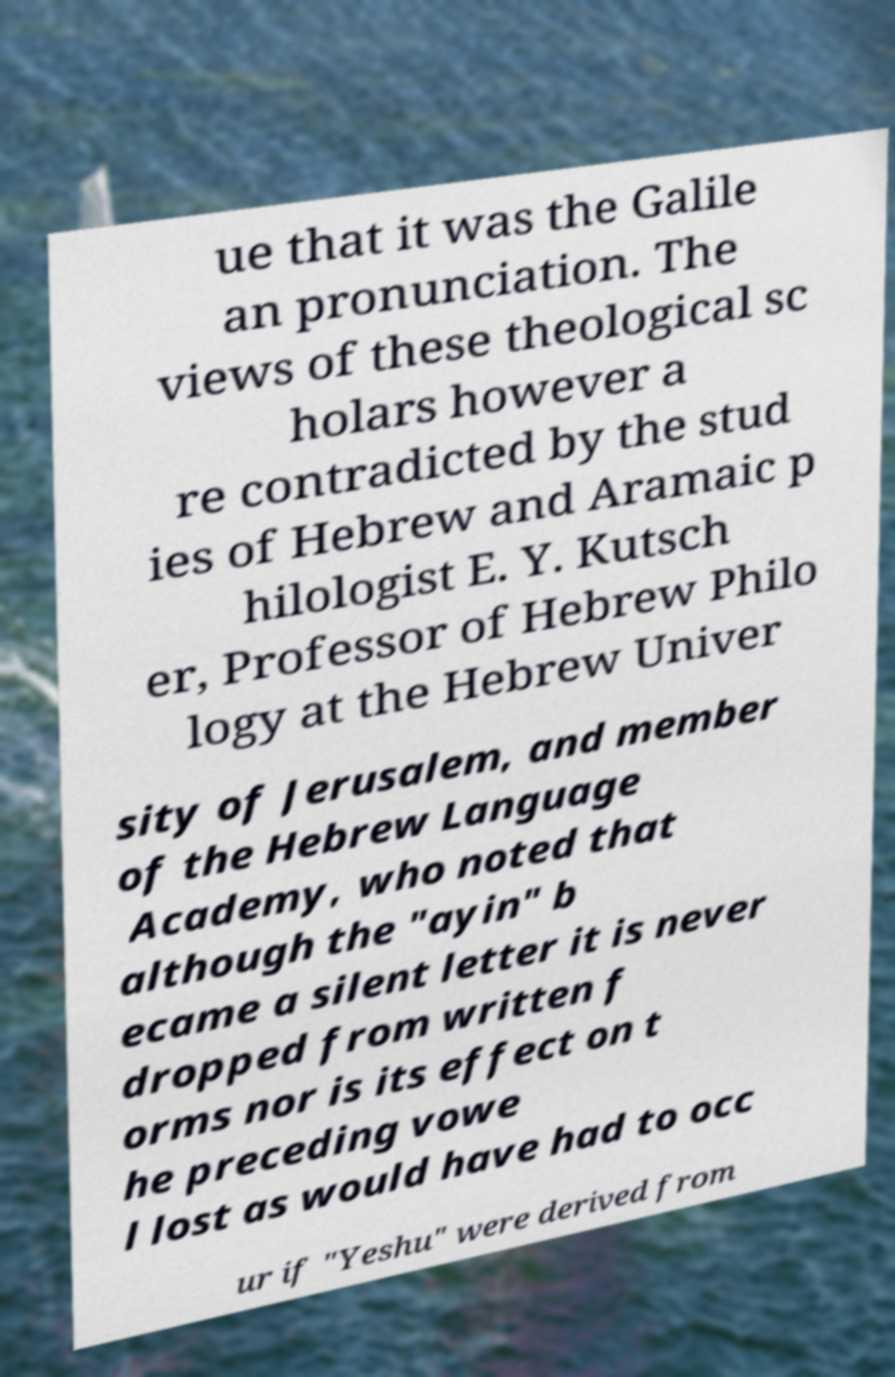There's text embedded in this image that I need extracted. Can you transcribe it verbatim? ue that it was the Galile an pronunciation. The views of these theological sc holars however a re contradicted by the stud ies of Hebrew and Aramaic p hilologist E. Y. Kutsch er, Professor of Hebrew Philo logy at the Hebrew Univer sity of Jerusalem, and member of the Hebrew Language Academy, who noted that although the "ayin" b ecame a silent letter it is never dropped from written f orms nor is its effect on t he preceding vowe l lost as would have had to occ ur if "Yeshu" were derived from 